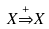Convert formula to latex. <formula><loc_0><loc_0><loc_500><loc_500>X { \stackrel { + } { \Rightarrow } } X</formula> 